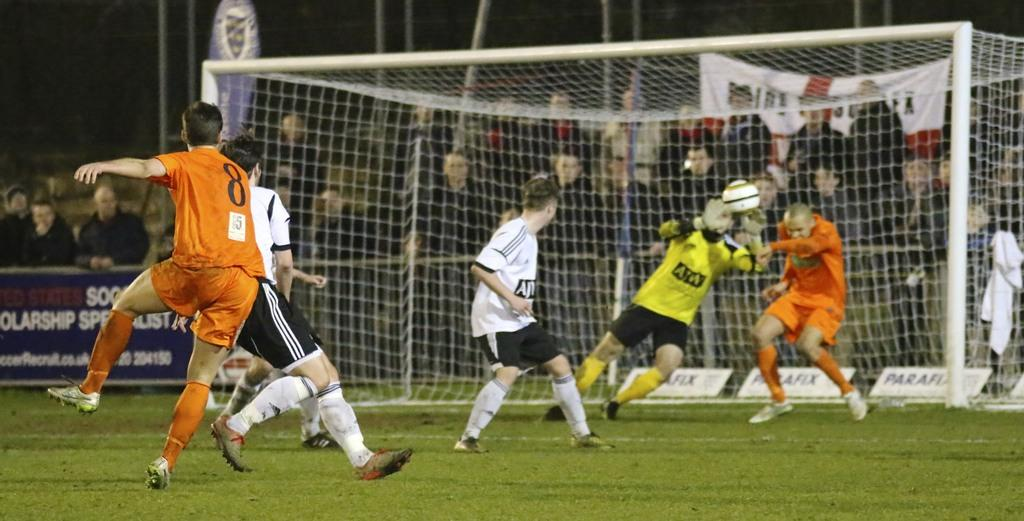<image>
Write a terse but informative summary of the picture. Player number 8 on the orange team has just kicked the ball and is still in the air. 